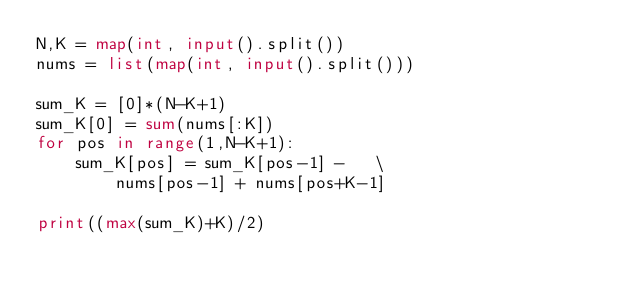<code> <loc_0><loc_0><loc_500><loc_500><_Python_>N,K = map(int, input().split())
nums = list(map(int, input().split()))

sum_K = [0]*(N-K+1)
sum_K[0] = sum(nums[:K])
for pos in range(1,N-K+1):
    sum_K[pos] = sum_K[pos-1] -   \
        nums[pos-1] + nums[pos+K-1]

print((max(sum_K)+K)/2)</code> 